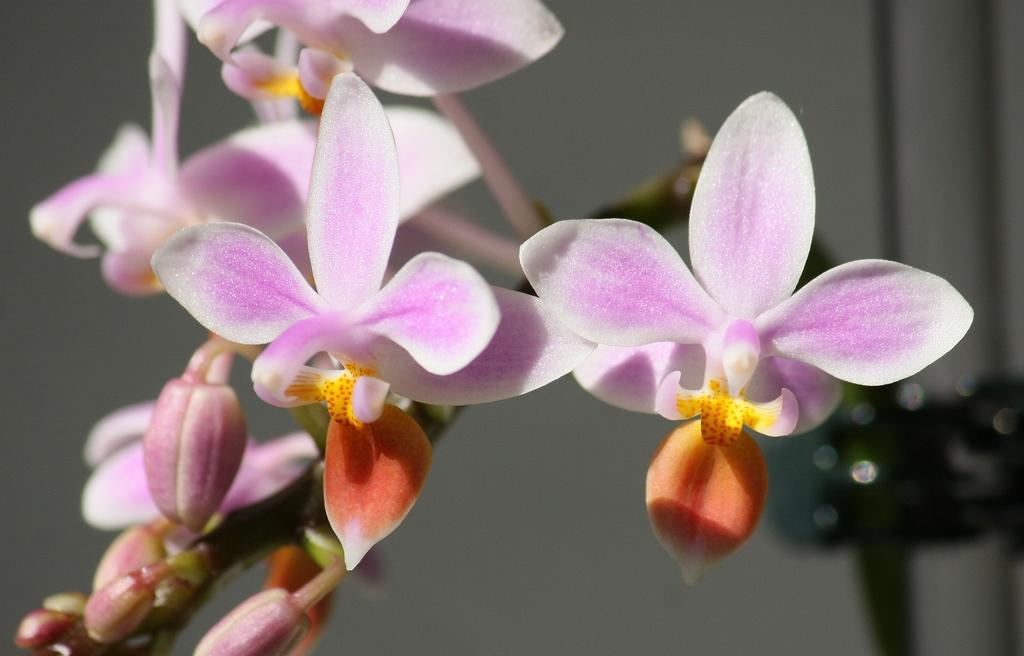What is the focus of the image? The image is a zoomed-in view. What can be seen in the foreground of the image? There are flowers and buds in the foreground of the image. What else can be seen in the image besides the flowers and buds? There are other objects visible in the background of the image. What type of spark can be seen coming from the farmer's tool in the image? There is no farmer or tool present in the image; it features flowers and buds in the foreground and other objects in the background. 